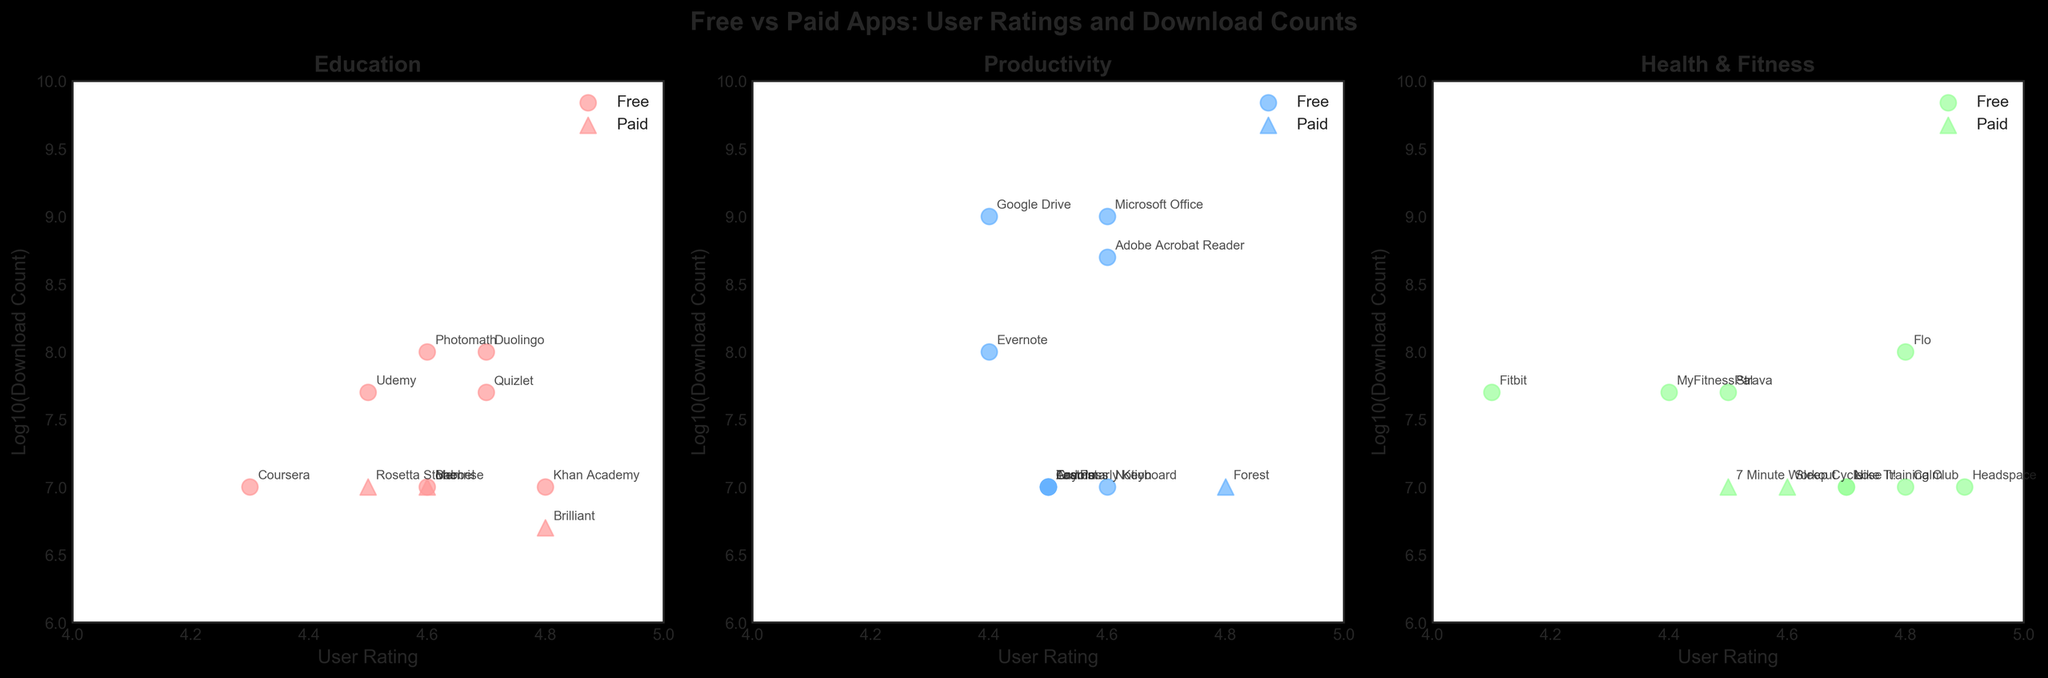What is the highest user rating among free apps in the Education category? To find this, look at the scatter plot for the Education category. Identify the data points representing free apps and compare their user ratings. The highest rating among these points is the answer
Answer: 4.8 Which category shows the largest difference in download counts between free and paid apps? Examine the scatter plots for each category and compare the highest log10(download_count) of free apps with that of paid apps within each category. The Health & Fitness category has the largest visible difference
Answer: Health & Fitness Which free app has the highest log10(download count) in all categories? Check all three scatter plots and identify the free app with the highest y-coordinate (log10(download_count)). The app with the highest value is in the Productivity category
Answer: Google Drive For Education, do more free apps or paid apps have user ratings above 4.6? Look at the scatter plot for the Education category and count the number of free and paid apps that have user ratings above 4.6. Compare the counts
Answer: More free apps In the Health & Fitness category, which type of app (free or paid) generally has higher download counts? Examine the scatter plot for Health & Fitness and compare the overall y-coordinates (log10(download_count)) of free and paid apps. Free apps generally have higher download counts
Answer: Free apps Which category has the closest user ratings between free and paid apps? Review each scatter plot and compare the range of user ratings for free and paid apps. The category with the smallest difference in user ratings is determined by observing how close the data points are
Answer: Productivity In the Productivity category, what is the average user rating for paid apps? Identify the paid apps in the Productivity category and calculate the average of their user ratings: (4.8) / 1 (since only Forest is a paid app)
Answer: 4.8 Which free app in the Entertainment category has a user rating below 4.5? Find the scatter plot for Entertainment and locate the free apps (circular markers) that have user ratings below 4.5. Identify the app name by the text annotation
Answer: YouTube 